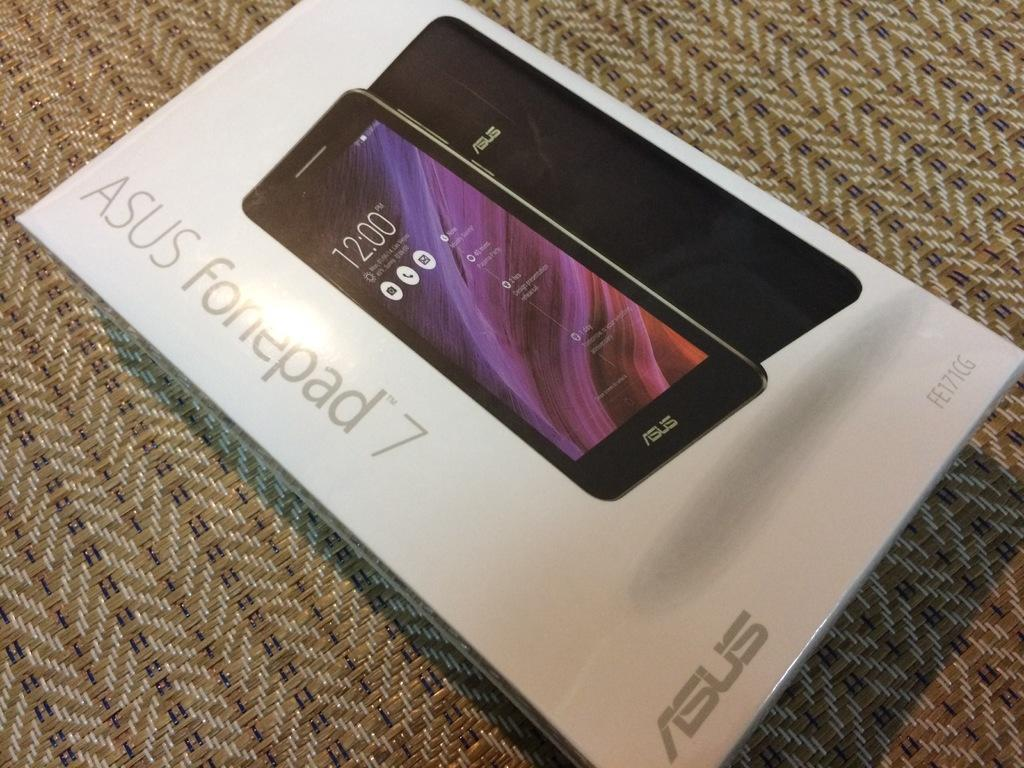<image>
Summarize the visual content of the image. The phone brand shown on the box is made by the company ASUS. 